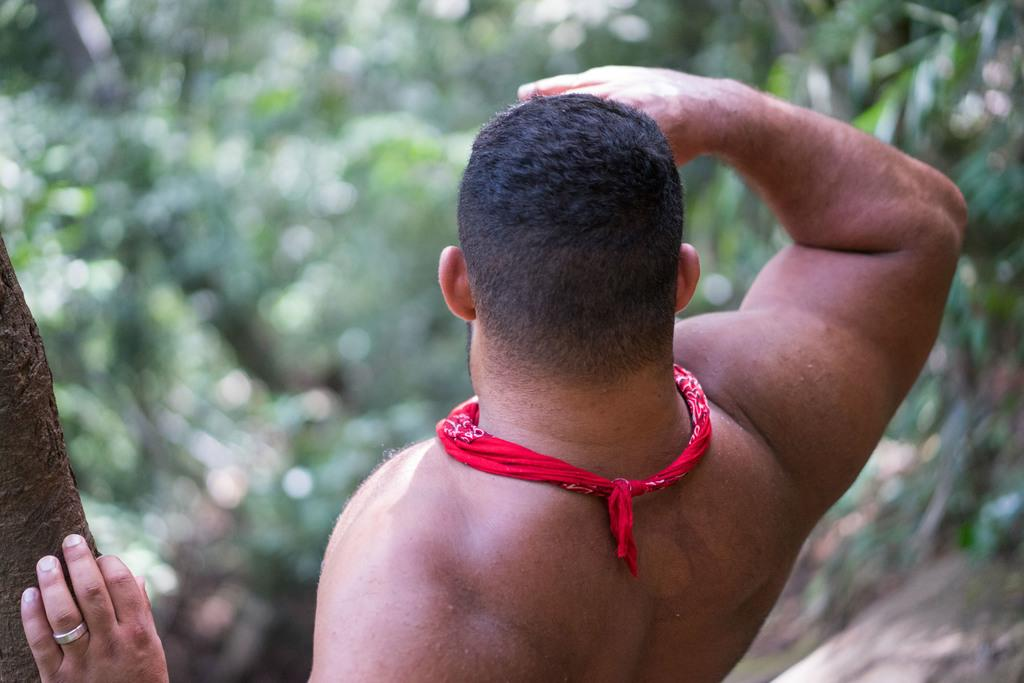What is present in the image? There is a man in the image. Can you describe the man's position in relation to the tree trunk? The man is standing beside a tree trunk. What can be seen in front of the man? There are many trees in front of the man. Can you see any mice hiding in the cave behind the man in the image? There is no cave or mice present in the image. 